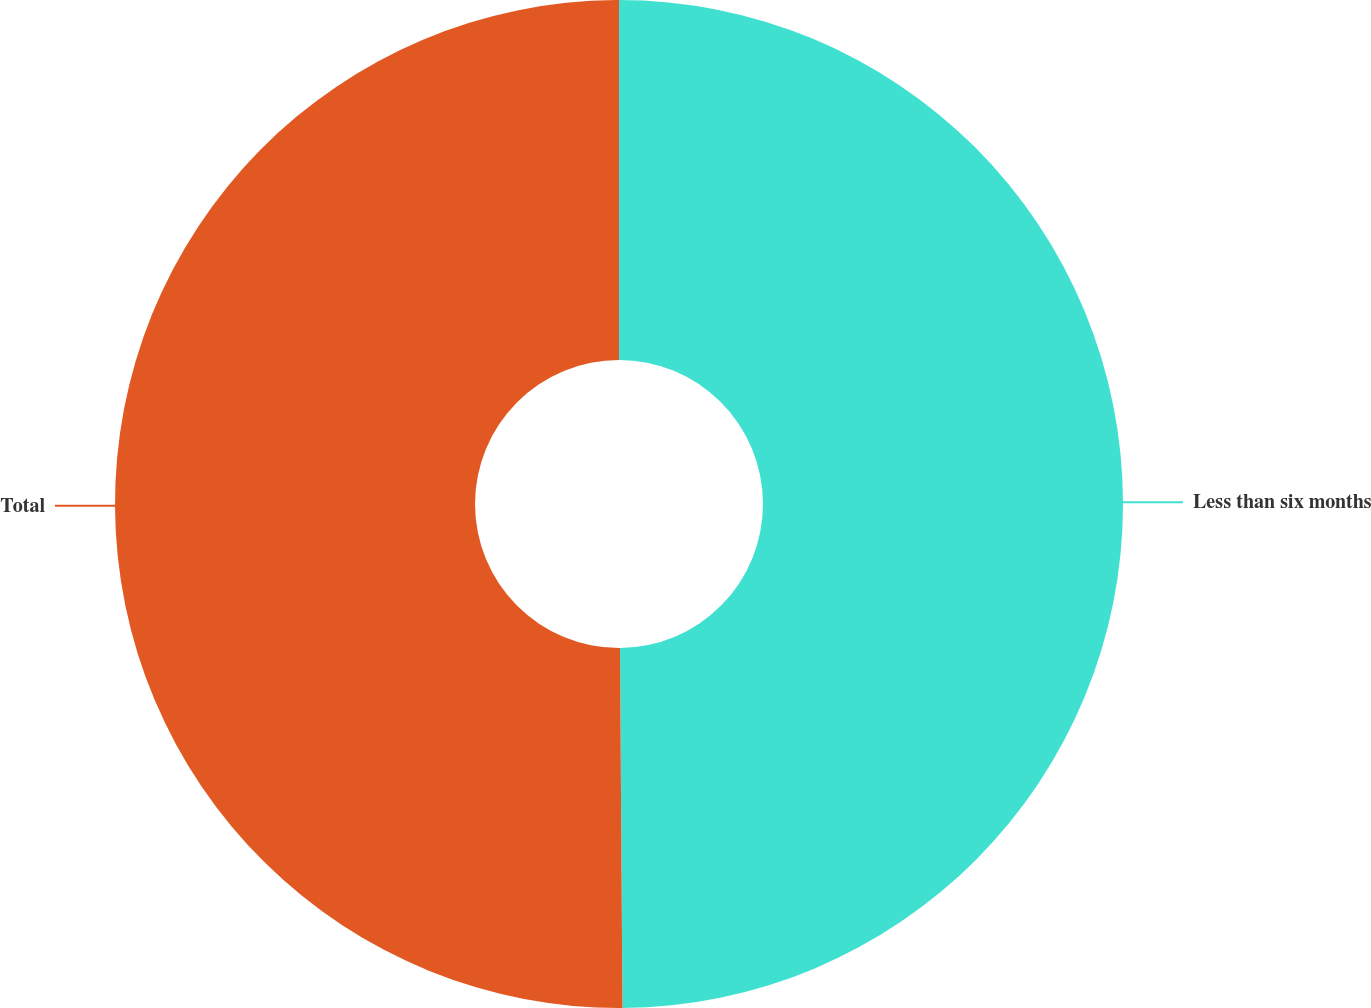Convert chart. <chart><loc_0><loc_0><loc_500><loc_500><pie_chart><fcel>Less than six months<fcel>Total<nl><fcel>49.89%<fcel>50.11%<nl></chart> 